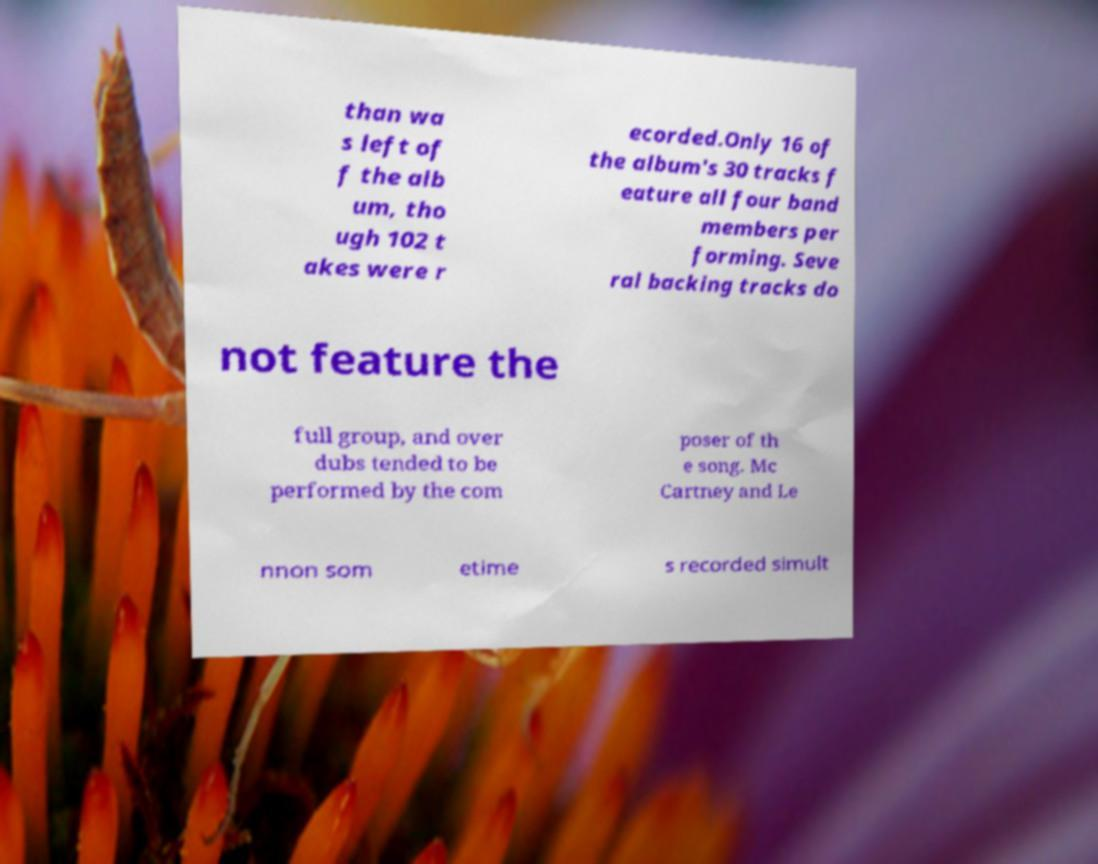Can you read and provide the text displayed in the image?This photo seems to have some interesting text. Can you extract and type it out for me? than wa s left of f the alb um, tho ugh 102 t akes were r ecorded.Only 16 of the album's 30 tracks f eature all four band members per forming. Seve ral backing tracks do not feature the full group, and over dubs tended to be performed by the com poser of th e song. Mc Cartney and Le nnon som etime s recorded simult 